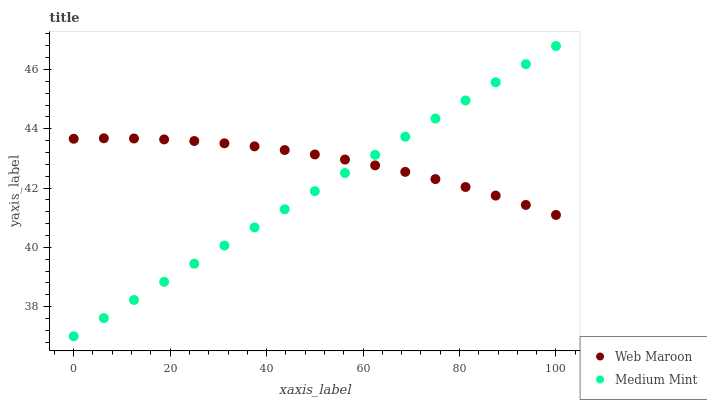Does Medium Mint have the minimum area under the curve?
Answer yes or no. Yes. Does Web Maroon have the maximum area under the curve?
Answer yes or no. Yes. Does Web Maroon have the minimum area under the curve?
Answer yes or no. No. Is Medium Mint the smoothest?
Answer yes or no. Yes. Is Web Maroon the roughest?
Answer yes or no. Yes. Is Web Maroon the smoothest?
Answer yes or no. No. Does Medium Mint have the lowest value?
Answer yes or no. Yes. Does Web Maroon have the lowest value?
Answer yes or no. No. Does Medium Mint have the highest value?
Answer yes or no. Yes. Does Web Maroon have the highest value?
Answer yes or no. No. Does Medium Mint intersect Web Maroon?
Answer yes or no. Yes. Is Medium Mint less than Web Maroon?
Answer yes or no. No. Is Medium Mint greater than Web Maroon?
Answer yes or no. No. 